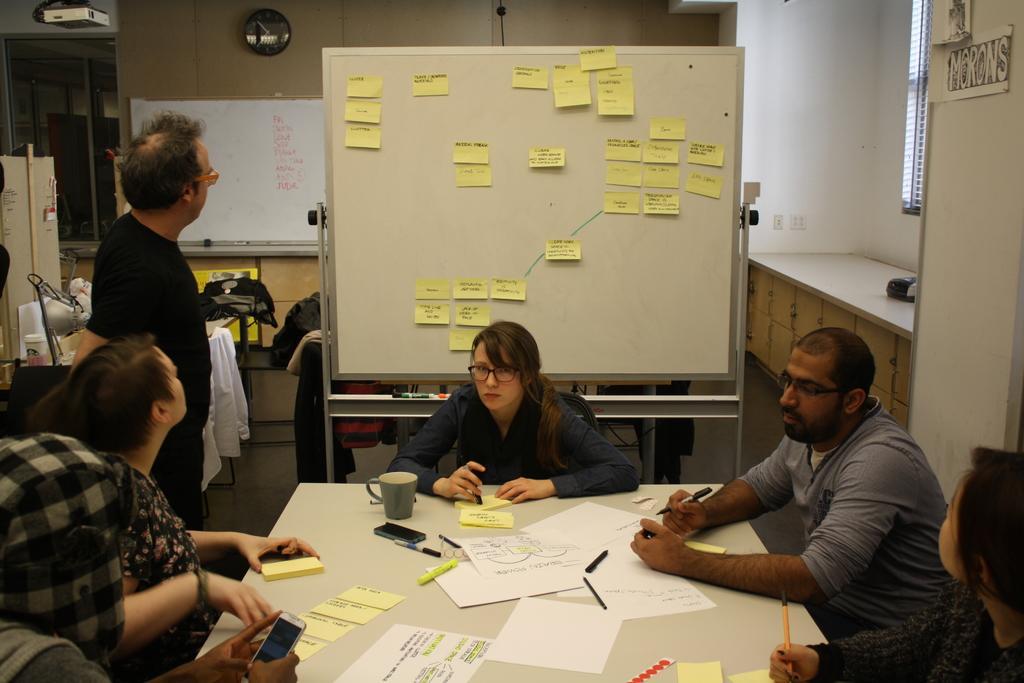Describe this image in one or two sentences. In this image, we can see people sitting and some are holding pens and one of them is holding a mobile and we can see a person standing. In the background, there are boards and we can see some stickers and there are cupboards, lights, boxes and there is a clock on the wall and some clothes on the table. At the bottom, there is a cup, papers and some pens are placed on the table. 